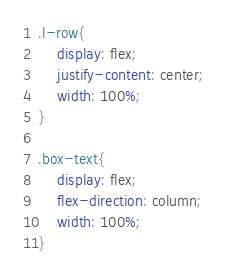<code> <loc_0><loc_0><loc_500><loc_500><_CSS_>.l-row{
    display: flex;
    justify-content: center;
    width: 100%;
}

.box-text{
    display: flex;
    flex-direction: column;
    width: 100%;
}</code> 